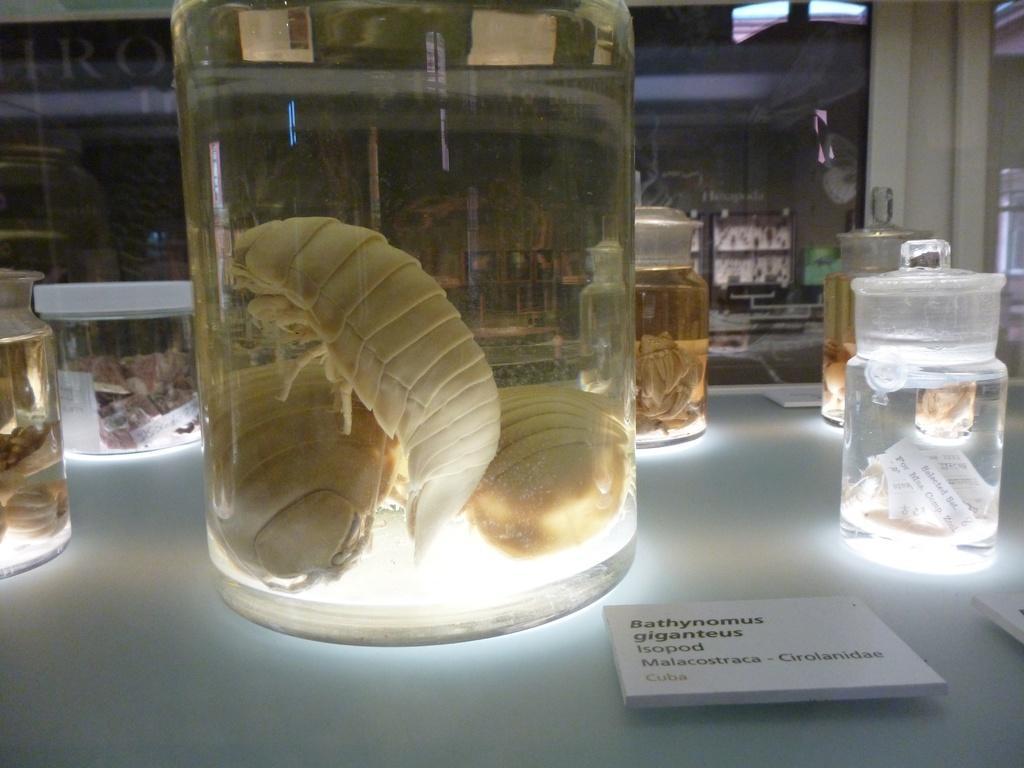Describe this image in one or two sentences. This looks like a lab. On this table there are few jars,in each jar there are some species. 